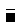<formula> <loc_0><loc_0><loc_500><loc_500>\overline { \Gamma }</formula> 